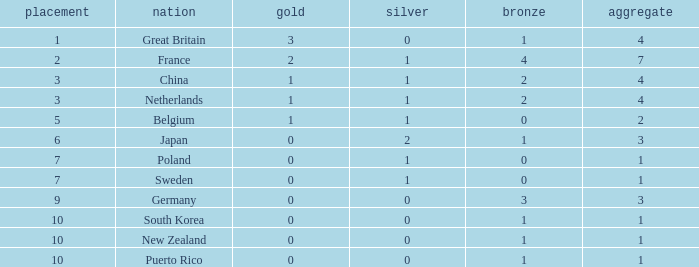What is the total where the gold is larger than 2? 1.0. 